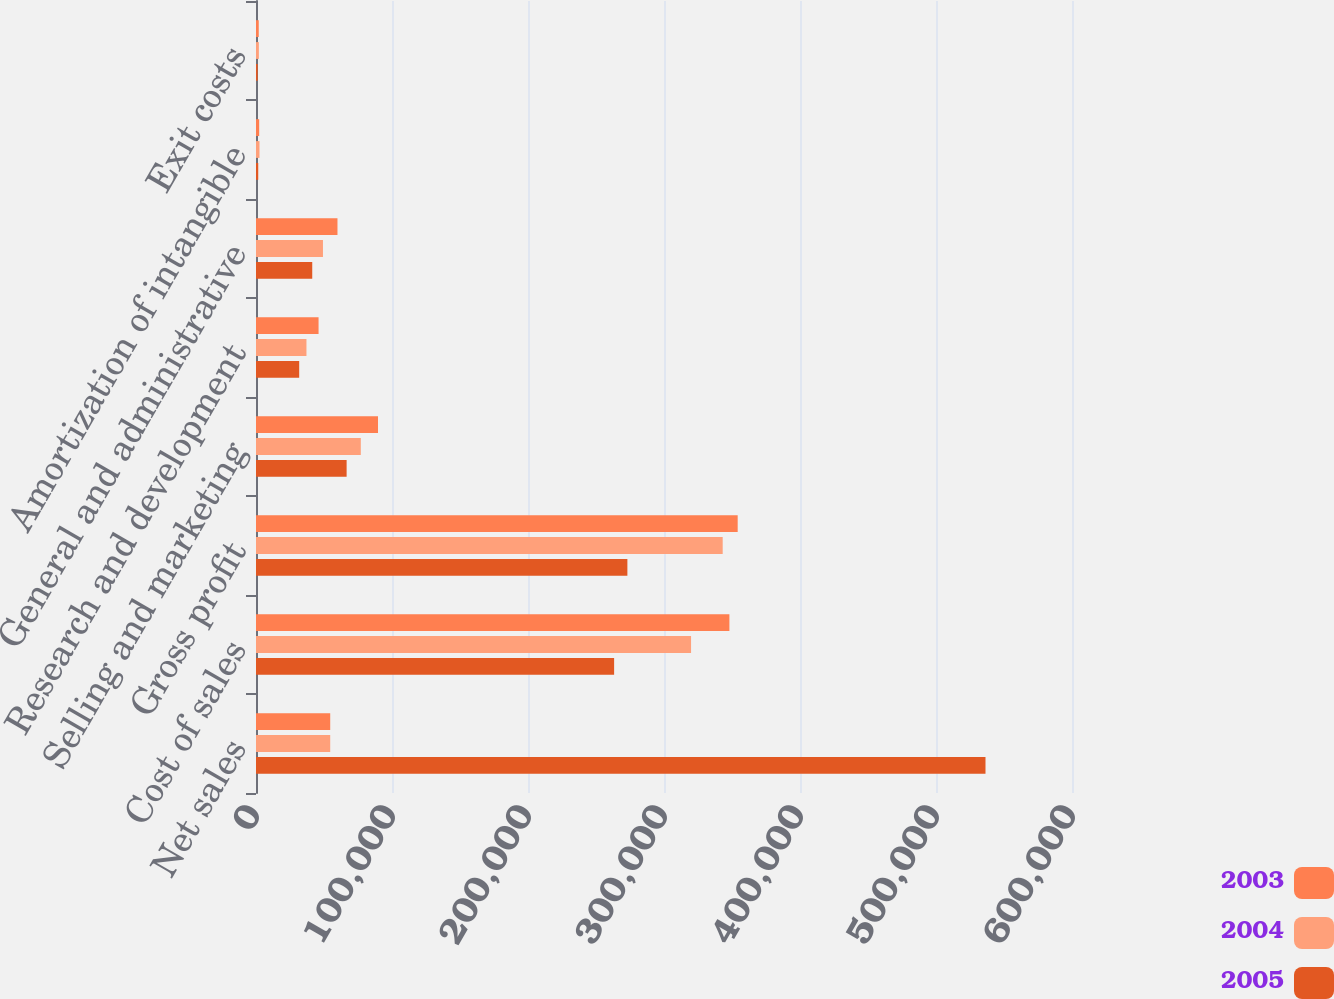Convert chart to OTSL. <chart><loc_0><loc_0><loc_500><loc_500><stacked_bar_chart><ecel><fcel>Net sales<fcel>Cost of sales<fcel>Gross profit<fcel>Selling and marketing<fcel>Research and development<fcel>General and administrative<fcel>Amortization of intangible<fcel>Exit costs<nl><fcel>2003<fcel>54575<fcel>348090<fcel>354181<fcel>89707<fcel>46000<fcel>59910<fcel>2341<fcel>2012<nl><fcel>2004<fcel>54575<fcel>319895<fcel>343159<fcel>77062<fcel>37093<fcel>49240<fcel>2569<fcel>2100<nl><fcel>2005<fcel>536397<fcel>263320<fcel>273077<fcel>66635<fcel>31759<fcel>41352<fcel>1640<fcel>1232<nl></chart> 